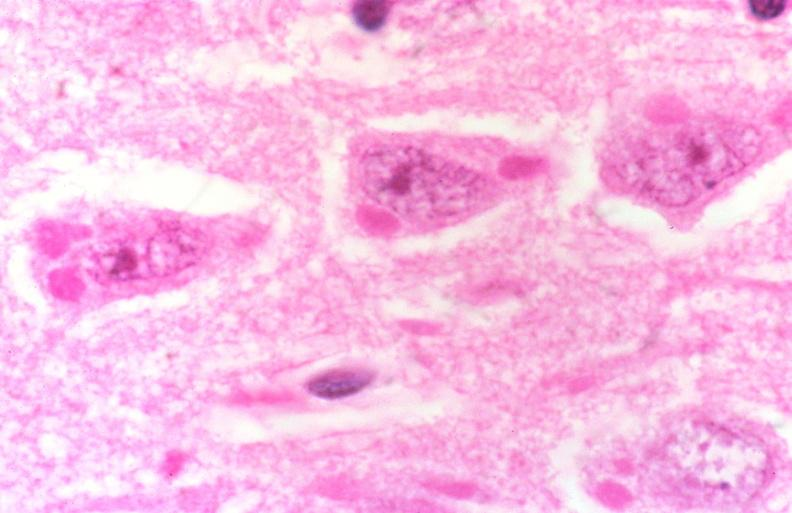what is present?
Answer the question using a single word or phrase. Nervous 